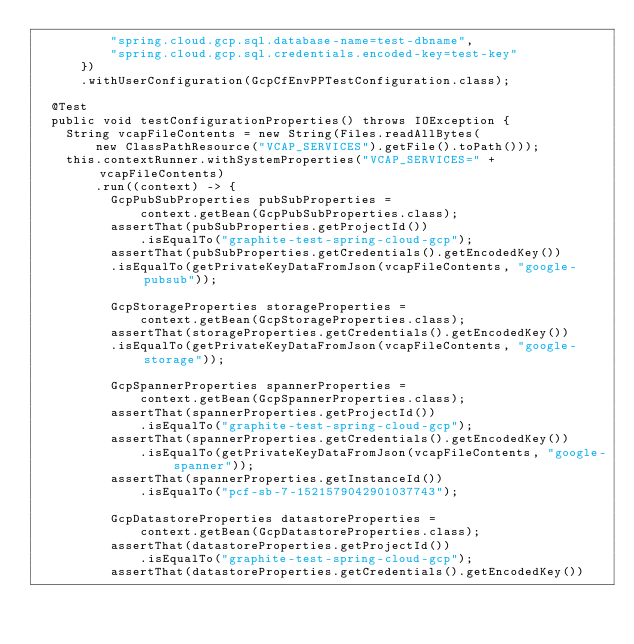<code> <loc_0><loc_0><loc_500><loc_500><_Java_>					"spring.cloud.gcp.sql.database-name=test-dbname",
					"spring.cloud.gcp.sql.credentials.encoded-key=test-key"
			})
			.withUserConfiguration(GcpCfEnvPPTestConfiguration.class);

	@Test
	public void testConfigurationProperties() throws IOException {
		String vcapFileContents = new String(Files.readAllBytes(
				new ClassPathResource("VCAP_SERVICES").getFile().toPath()));
		this.contextRunner.withSystemProperties("VCAP_SERVICES=" + vcapFileContents)
				.run((context) -> {
					GcpPubSubProperties pubSubProperties =
							context.getBean(GcpPubSubProperties.class);
					assertThat(pubSubProperties.getProjectId())
							.isEqualTo("graphite-test-spring-cloud-gcp");
					assertThat(pubSubProperties.getCredentials().getEncodedKey())
					.isEqualTo(getPrivateKeyDataFromJson(vcapFileContents, "google-pubsub"));

					GcpStorageProperties storageProperties =
							context.getBean(GcpStorageProperties.class);
					assertThat(storageProperties.getCredentials().getEncodedKey())
					.isEqualTo(getPrivateKeyDataFromJson(vcapFileContents, "google-storage"));

					GcpSpannerProperties spannerProperties =
							context.getBean(GcpSpannerProperties.class);
					assertThat(spannerProperties.getProjectId())
							.isEqualTo("graphite-test-spring-cloud-gcp");
					assertThat(spannerProperties.getCredentials().getEncodedKey())
							.isEqualTo(getPrivateKeyDataFromJson(vcapFileContents, "google-spanner"));
					assertThat(spannerProperties.getInstanceId())
							.isEqualTo("pcf-sb-7-1521579042901037743");

					GcpDatastoreProperties datastoreProperties =
							context.getBean(GcpDatastoreProperties.class);
					assertThat(datastoreProperties.getProjectId())
							.isEqualTo("graphite-test-spring-cloud-gcp");
					assertThat(datastoreProperties.getCredentials().getEncodedKey())</code> 